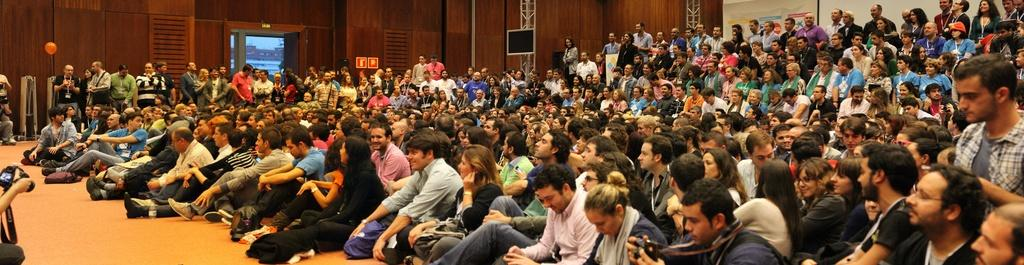How many people are in the room? There are many people in the room. What are some of the people in the room doing? Some people are standing. Can you describe the room's layout? There is a door in the room, and there are sign boards at the back of the room. Who is holding a camera in the image? A person at the left is holding a camera. What type of kite is hanging on the wall in the image? There is no kite present in the image. Can you describe the vase on the table in the image? There is no vase present in the image. 